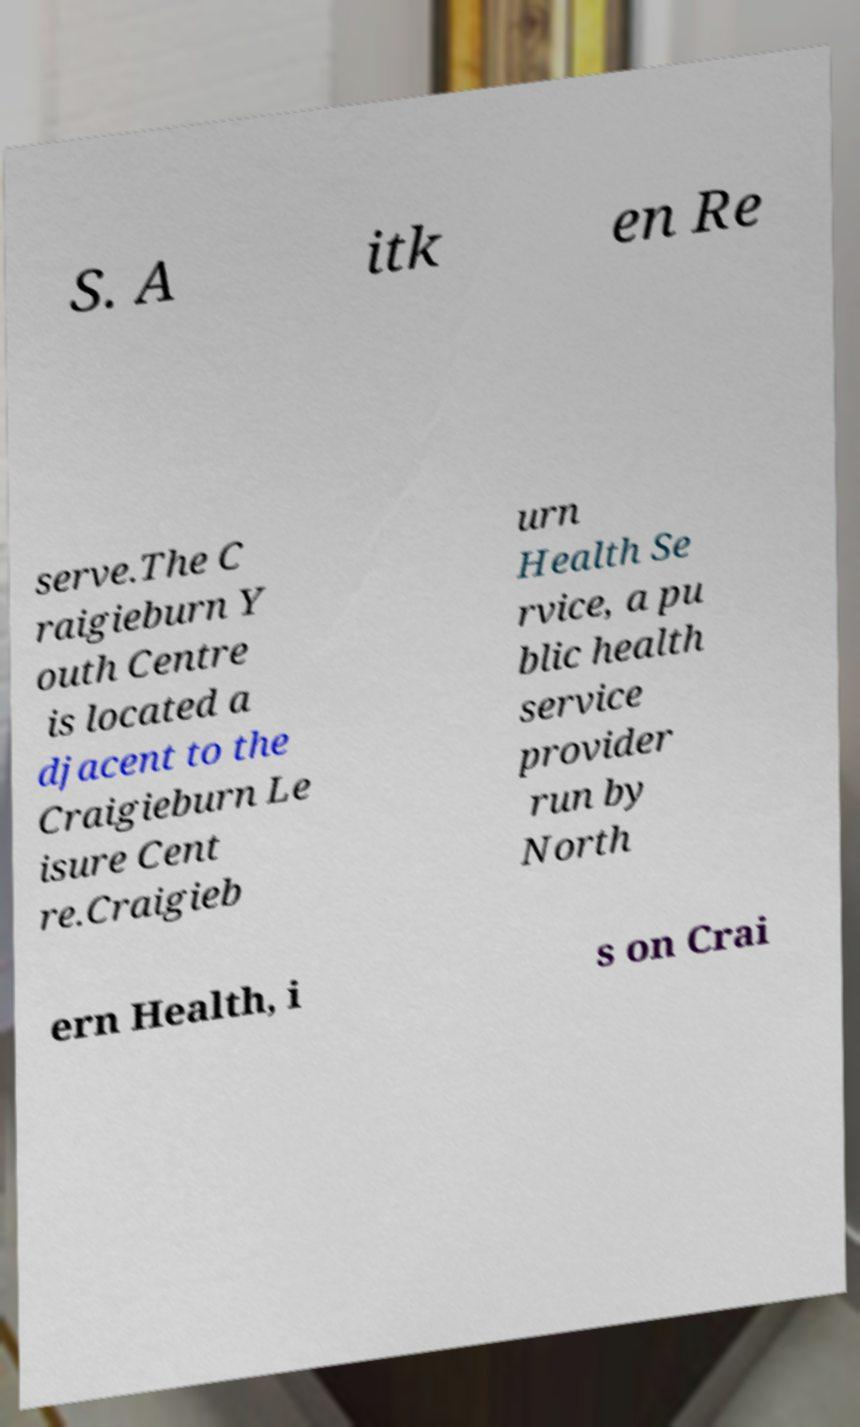What messages or text are displayed in this image? I need them in a readable, typed format. S. A itk en Re serve.The C raigieburn Y outh Centre is located a djacent to the Craigieburn Le isure Cent re.Craigieb urn Health Se rvice, a pu blic health service provider run by North ern Health, i s on Crai 